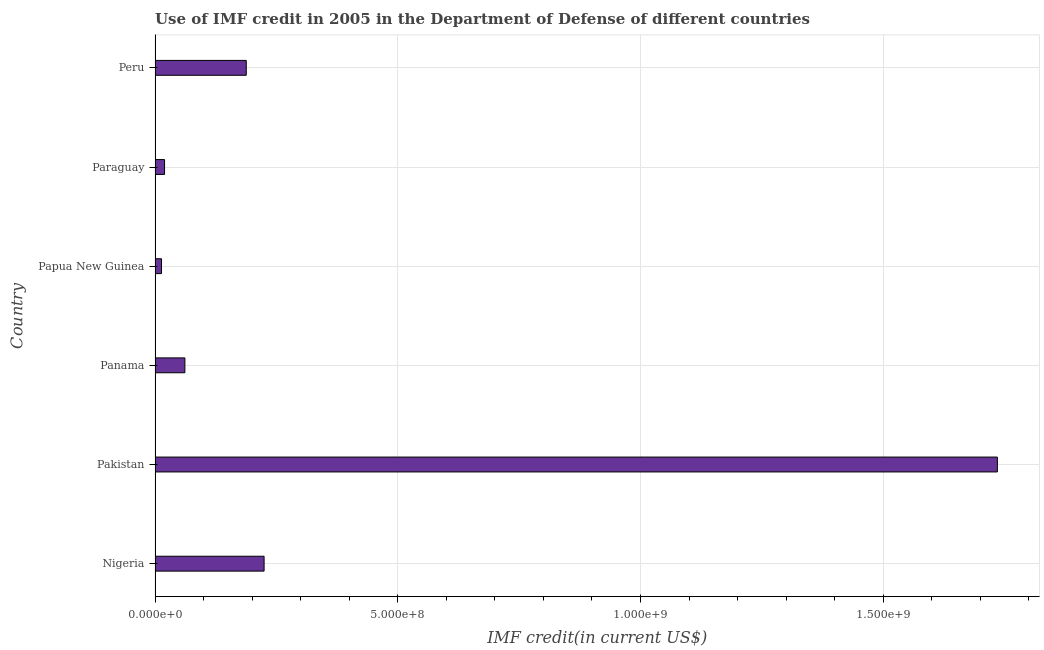Does the graph contain any zero values?
Keep it short and to the point. No. What is the title of the graph?
Give a very brief answer. Use of IMF credit in 2005 in the Department of Defense of different countries. What is the label or title of the X-axis?
Keep it short and to the point. IMF credit(in current US$). What is the use of imf credit in dod in Nigeria?
Offer a terse response. 2.25e+08. Across all countries, what is the maximum use of imf credit in dod?
Offer a very short reply. 1.74e+09. Across all countries, what is the minimum use of imf credit in dod?
Your response must be concise. 1.33e+07. In which country was the use of imf credit in dod maximum?
Offer a very short reply. Pakistan. In which country was the use of imf credit in dod minimum?
Your answer should be compact. Papua New Guinea. What is the sum of the use of imf credit in dod?
Keep it short and to the point. 2.24e+09. What is the difference between the use of imf credit in dod in Panama and Paraguay?
Make the answer very short. 4.19e+07. What is the average use of imf credit in dod per country?
Your response must be concise. 3.74e+08. What is the median use of imf credit in dod?
Ensure brevity in your answer.  1.25e+08. What is the ratio of the use of imf credit in dod in Panama to that in Papua New Guinea?
Your response must be concise. 4.62. Is the difference between the use of imf credit in dod in Pakistan and Panama greater than the difference between any two countries?
Ensure brevity in your answer.  No. What is the difference between the highest and the second highest use of imf credit in dod?
Your answer should be very brief. 1.51e+09. Is the sum of the use of imf credit in dod in Pakistan and Paraguay greater than the maximum use of imf credit in dod across all countries?
Your answer should be compact. Yes. What is the difference between the highest and the lowest use of imf credit in dod?
Make the answer very short. 1.72e+09. How many bars are there?
Your answer should be compact. 6. How many countries are there in the graph?
Give a very brief answer. 6. What is the difference between two consecutive major ticks on the X-axis?
Make the answer very short. 5.00e+08. Are the values on the major ticks of X-axis written in scientific E-notation?
Make the answer very short. Yes. What is the IMF credit(in current US$) in Nigeria?
Provide a short and direct response. 2.25e+08. What is the IMF credit(in current US$) of Pakistan?
Give a very brief answer. 1.74e+09. What is the IMF credit(in current US$) of Panama?
Give a very brief answer. 6.14e+07. What is the IMF credit(in current US$) in Papua New Guinea?
Your answer should be very brief. 1.33e+07. What is the IMF credit(in current US$) of Paraguay?
Provide a succinct answer. 1.96e+07. What is the IMF credit(in current US$) in Peru?
Your response must be concise. 1.88e+08. What is the difference between the IMF credit(in current US$) in Nigeria and Pakistan?
Your answer should be compact. -1.51e+09. What is the difference between the IMF credit(in current US$) in Nigeria and Panama?
Offer a terse response. 1.63e+08. What is the difference between the IMF credit(in current US$) in Nigeria and Papua New Guinea?
Your answer should be very brief. 2.11e+08. What is the difference between the IMF credit(in current US$) in Nigeria and Paraguay?
Provide a short and direct response. 2.05e+08. What is the difference between the IMF credit(in current US$) in Nigeria and Peru?
Keep it short and to the point. 3.67e+07. What is the difference between the IMF credit(in current US$) in Pakistan and Panama?
Provide a succinct answer. 1.67e+09. What is the difference between the IMF credit(in current US$) in Pakistan and Papua New Guinea?
Keep it short and to the point. 1.72e+09. What is the difference between the IMF credit(in current US$) in Pakistan and Paraguay?
Your response must be concise. 1.72e+09. What is the difference between the IMF credit(in current US$) in Pakistan and Peru?
Ensure brevity in your answer.  1.55e+09. What is the difference between the IMF credit(in current US$) in Panama and Papua New Guinea?
Offer a very short reply. 4.82e+07. What is the difference between the IMF credit(in current US$) in Panama and Paraguay?
Give a very brief answer. 4.19e+07. What is the difference between the IMF credit(in current US$) in Panama and Peru?
Make the answer very short. -1.26e+08. What is the difference between the IMF credit(in current US$) in Papua New Guinea and Paraguay?
Offer a very short reply. -6.28e+06. What is the difference between the IMF credit(in current US$) in Papua New Guinea and Peru?
Offer a terse response. -1.75e+08. What is the difference between the IMF credit(in current US$) in Paraguay and Peru?
Keep it short and to the point. -1.68e+08. What is the ratio of the IMF credit(in current US$) in Nigeria to that in Pakistan?
Provide a short and direct response. 0.13. What is the ratio of the IMF credit(in current US$) in Nigeria to that in Panama?
Make the answer very short. 3.66. What is the ratio of the IMF credit(in current US$) in Nigeria to that in Papua New Guinea?
Keep it short and to the point. 16.9. What is the ratio of the IMF credit(in current US$) in Nigeria to that in Paraguay?
Make the answer very short. 11.47. What is the ratio of the IMF credit(in current US$) in Nigeria to that in Peru?
Your response must be concise. 1.2. What is the ratio of the IMF credit(in current US$) in Pakistan to that in Panama?
Provide a short and direct response. 28.24. What is the ratio of the IMF credit(in current US$) in Pakistan to that in Papua New Guinea?
Your answer should be very brief. 130.54. What is the ratio of the IMF credit(in current US$) in Pakistan to that in Paraguay?
Ensure brevity in your answer.  88.63. What is the ratio of the IMF credit(in current US$) in Pakistan to that in Peru?
Your answer should be compact. 9.24. What is the ratio of the IMF credit(in current US$) in Panama to that in Papua New Guinea?
Your response must be concise. 4.62. What is the ratio of the IMF credit(in current US$) in Panama to that in Paraguay?
Ensure brevity in your answer.  3.14. What is the ratio of the IMF credit(in current US$) in Panama to that in Peru?
Offer a terse response. 0.33. What is the ratio of the IMF credit(in current US$) in Papua New Guinea to that in Paraguay?
Provide a short and direct response. 0.68. What is the ratio of the IMF credit(in current US$) in Papua New Guinea to that in Peru?
Provide a succinct answer. 0.07. What is the ratio of the IMF credit(in current US$) in Paraguay to that in Peru?
Make the answer very short. 0.1. 